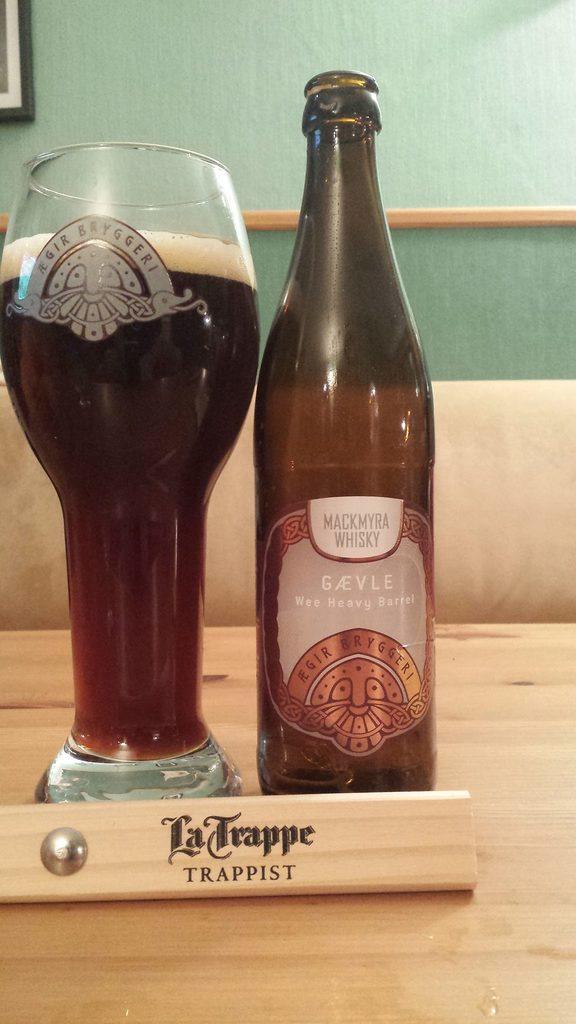In one or two sentences, can you explain what this image depicts? in this image we can able to see a wine bottle, and a glass filler with wine on the table, there is a display card with text on it, and we can see a wall, and a frame. 